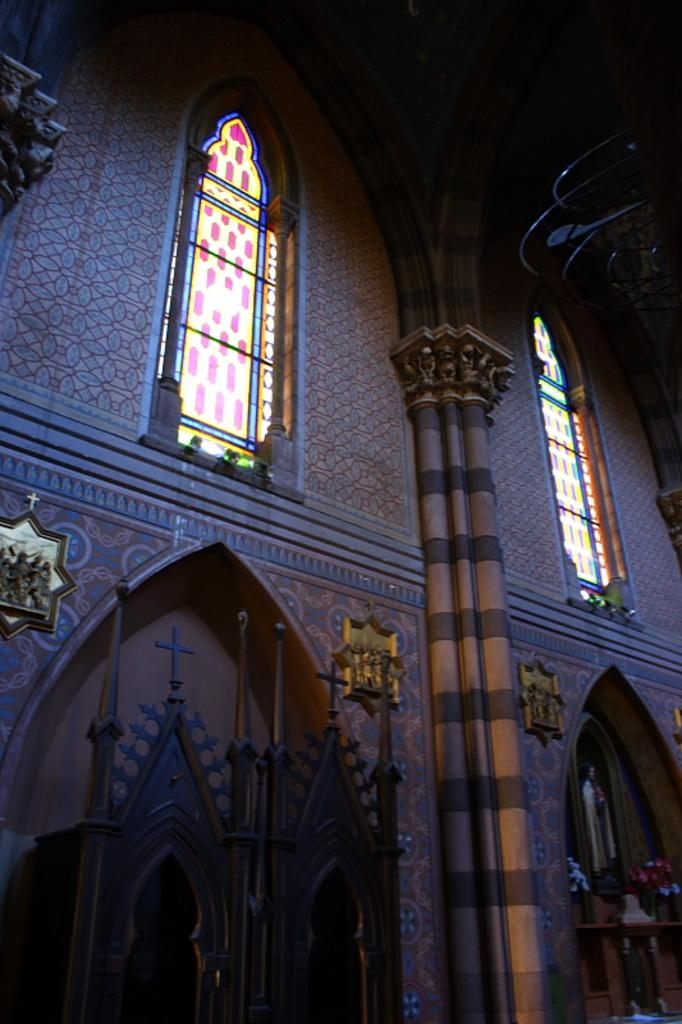What is the main subject of the image? The main subject of the image is a building. Can you describe the background of the image? The background of the image is dark. What type of cast is visible on the building in the image? There is no cast visible on the building in the image. What type of connection does the building have with the achiever in the image? There is no achiever present in the image, so no connection can be established. 